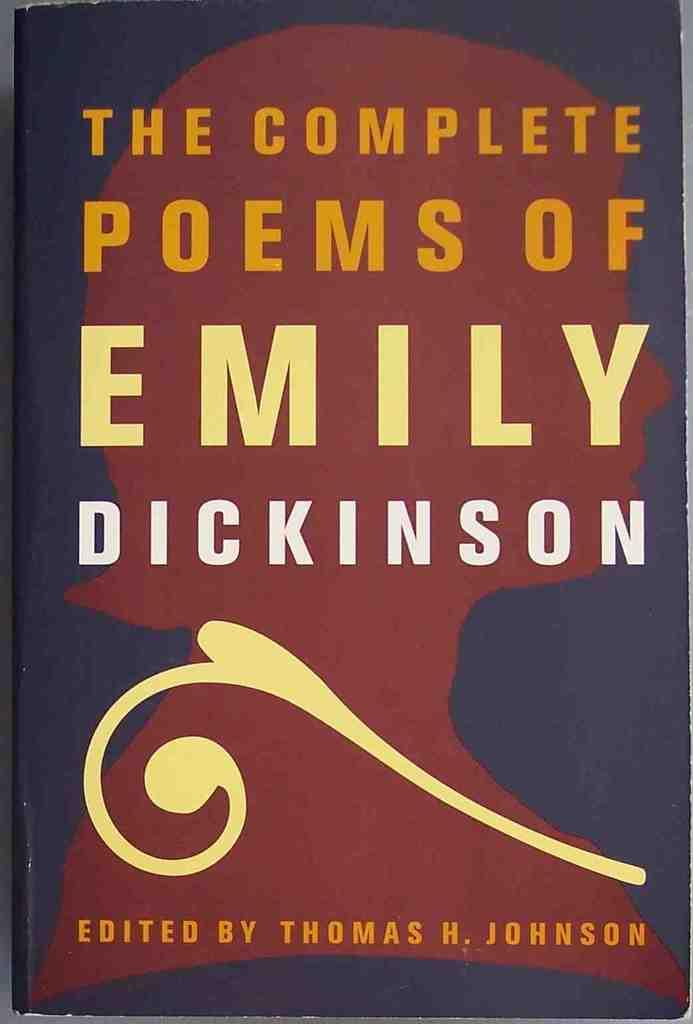<image>
Relay a brief, clear account of the picture shown. A cover of the Complete Poems of Emily Dickinson. 